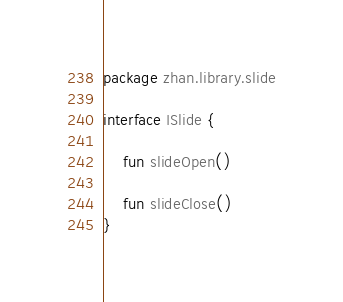<code> <loc_0><loc_0><loc_500><loc_500><_Kotlin_>package zhan.library.slide

interface ISlide {

    fun slideOpen()

    fun slideClose()
}
</code> 